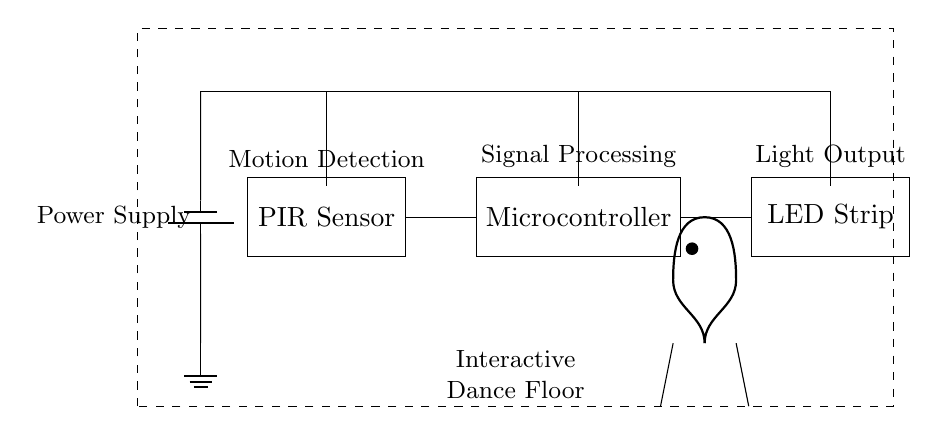What component is used to detect motion? The component used to detect motion is the PIR Sensor, which is specifically labeled in the circuit.
Answer: PIR Sensor What outputs light when motion is detected? The component that outputs light when motion is detected is the LED Strip, as indicated in the circuit.
Answer: LED Strip How many main components are present in this circuit? The circuit features three main components, which are the PIR Sensor, Microcontroller, and LED Strip.
Answer: 3 What is the function of the Microcontroller in this circuit? The Microcontroller processes the signal received from the PIR Sensor to control the LED Strip. This is implied by its position in the circuit diagram.
Answer: Signal Processing Which component is responsible for supplying power? The component responsible for supplying power is the Battery, as depicted and indicated in the circuit diagram.
Answer: Battery What does the dashed rectangle represent in the diagram? The dashed rectangle represents the interactive dance floor, which encompasses the electronic components and their functional area for motion detection.
Answer: Interactive Dance Floor How does the PIR Sensor interact with the Microcontroller? The PIR Sensor emits a signal based on motion detection, which is then sent to the Microcontroller for processing; their direct connection confirms this interaction.
Answer: Direct connection 